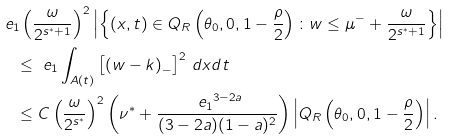Convert formula to latex. <formula><loc_0><loc_0><loc_500><loc_500>& \ e _ { 1 } \left ( \frac { \omega } { 2 ^ { s ^ { \ast } + 1 } } \right ) ^ { 2 } \left | \left \{ ( x , t ) \in Q _ { R } \left ( \theta _ { 0 } , 0 , 1 - \frac { \rho } { 2 } \right ) \colon w \leq \mu ^ { - } + \frac { \omega } { 2 ^ { s ^ { \ast } + 1 } } \right \} \right | \\ & \quad \leq \ e _ { 1 } \int _ { A ( t ) } \left [ \left ( w - k \right ) _ { - } \right ] ^ { 2 } \, d x d t \\ & \quad \leq C \left ( \frac { \omega } { 2 ^ { s ^ { \ast } } } \right ) ^ { 2 } \left ( \nu ^ { \ast } + \frac { { \ e _ { 1 } } ^ { 3 - 2 a } } { ( 3 - 2 a ) ( 1 - a ) ^ { 2 } } \right ) \left | Q _ { R } \left ( \theta _ { 0 } , 0 , 1 - \frac { \rho } { 2 } \right ) \right | .</formula> 